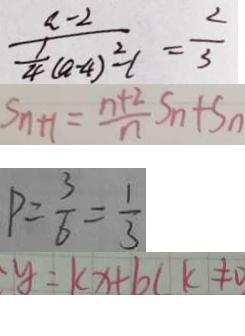<formula> <loc_0><loc_0><loc_500><loc_500>\frac { a - 2 } { \frac { 1 } { 4 } ( a - 4 ) ^ { 2 } - 1 } = \frac { 2 } { 3 } 
 S _ { n + 1 } = \frac { n + 2 } { n } S _ { n } + S _ { n } 
 P = \frac { 3 } { 6 } = \frac { 1 } { 3 } 
 y = k x + b ( k \neq 0 )</formula> 